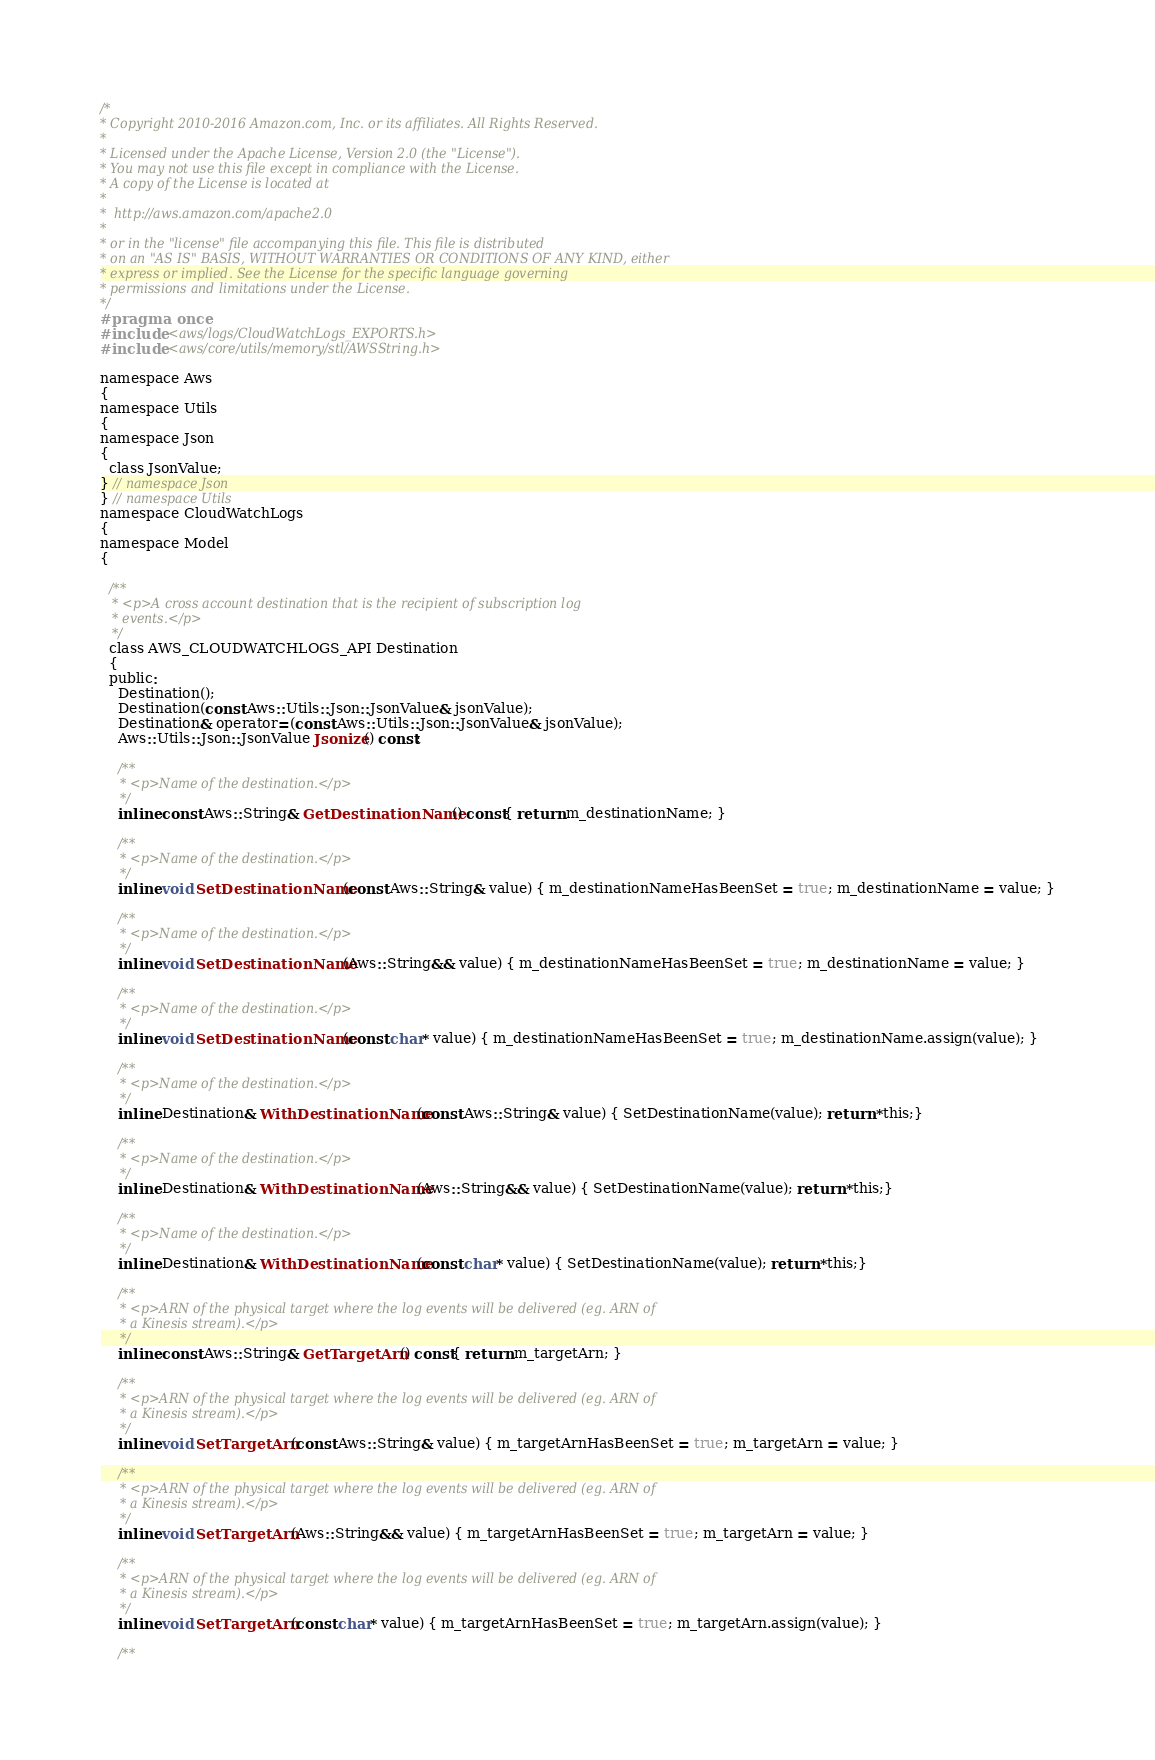Convert code to text. <code><loc_0><loc_0><loc_500><loc_500><_C_>/*
* Copyright 2010-2016 Amazon.com, Inc. or its affiliates. All Rights Reserved.
*
* Licensed under the Apache License, Version 2.0 (the "License").
* You may not use this file except in compliance with the License.
* A copy of the License is located at
*
*  http://aws.amazon.com/apache2.0
*
* or in the "license" file accompanying this file. This file is distributed
* on an "AS IS" BASIS, WITHOUT WARRANTIES OR CONDITIONS OF ANY KIND, either
* express or implied. See the License for the specific language governing
* permissions and limitations under the License.
*/
#pragma once
#include <aws/logs/CloudWatchLogs_EXPORTS.h>
#include <aws/core/utils/memory/stl/AWSString.h>

namespace Aws
{
namespace Utils
{
namespace Json
{
  class JsonValue;
} // namespace Json
} // namespace Utils
namespace CloudWatchLogs
{
namespace Model
{

  /**
   * <p>A cross account destination that is the recipient of subscription log
   * events.</p>
   */
  class AWS_CLOUDWATCHLOGS_API Destination
  {
  public:
    Destination();
    Destination(const Aws::Utils::Json::JsonValue& jsonValue);
    Destination& operator=(const Aws::Utils::Json::JsonValue& jsonValue);
    Aws::Utils::Json::JsonValue Jsonize() const;

    /**
     * <p>Name of the destination.</p>
     */
    inline const Aws::String& GetDestinationName() const{ return m_destinationName; }

    /**
     * <p>Name of the destination.</p>
     */
    inline void SetDestinationName(const Aws::String& value) { m_destinationNameHasBeenSet = true; m_destinationName = value; }

    /**
     * <p>Name of the destination.</p>
     */
    inline void SetDestinationName(Aws::String&& value) { m_destinationNameHasBeenSet = true; m_destinationName = value; }

    /**
     * <p>Name of the destination.</p>
     */
    inline void SetDestinationName(const char* value) { m_destinationNameHasBeenSet = true; m_destinationName.assign(value); }

    /**
     * <p>Name of the destination.</p>
     */
    inline Destination& WithDestinationName(const Aws::String& value) { SetDestinationName(value); return *this;}

    /**
     * <p>Name of the destination.</p>
     */
    inline Destination& WithDestinationName(Aws::String&& value) { SetDestinationName(value); return *this;}

    /**
     * <p>Name of the destination.</p>
     */
    inline Destination& WithDestinationName(const char* value) { SetDestinationName(value); return *this;}

    /**
     * <p>ARN of the physical target where the log events will be delivered (eg. ARN of
     * a Kinesis stream).</p>
     */
    inline const Aws::String& GetTargetArn() const{ return m_targetArn; }

    /**
     * <p>ARN of the physical target where the log events will be delivered (eg. ARN of
     * a Kinesis stream).</p>
     */
    inline void SetTargetArn(const Aws::String& value) { m_targetArnHasBeenSet = true; m_targetArn = value; }

    /**
     * <p>ARN of the physical target where the log events will be delivered (eg. ARN of
     * a Kinesis stream).</p>
     */
    inline void SetTargetArn(Aws::String&& value) { m_targetArnHasBeenSet = true; m_targetArn = value; }

    /**
     * <p>ARN of the physical target where the log events will be delivered (eg. ARN of
     * a Kinesis stream).</p>
     */
    inline void SetTargetArn(const char* value) { m_targetArnHasBeenSet = true; m_targetArn.assign(value); }

    /**</code> 